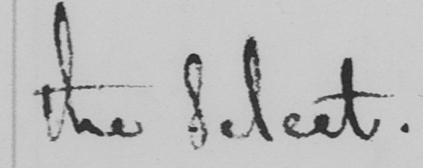Transcribe the text shown in this historical manuscript line. the Select . 